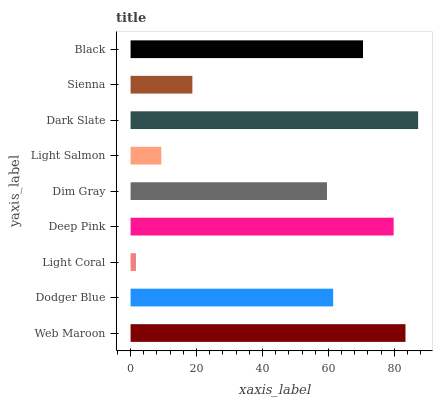Is Light Coral the minimum?
Answer yes or no. Yes. Is Dark Slate the maximum?
Answer yes or no. Yes. Is Dodger Blue the minimum?
Answer yes or no. No. Is Dodger Blue the maximum?
Answer yes or no. No. Is Web Maroon greater than Dodger Blue?
Answer yes or no. Yes. Is Dodger Blue less than Web Maroon?
Answer yes or no. Yes. Is Dodger Blue greater than Web Maroon?
Answer yes or no. No. Is Web Maroon less than Dodger Blue?
Answer yes or no. No. Is Dodger Blue the high median?
Answer yes or no. Yes. Is Dodger Blue the low median?
Answer yes or no. Yes. Is Sienna the high median?
Answer yes or no. No. Is Sienna the low median?
Answer yes or no. No. 